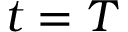Convert formula to latex. <formula><loc_0><loc_0><loc_500><loc_500>t = T</formula> 